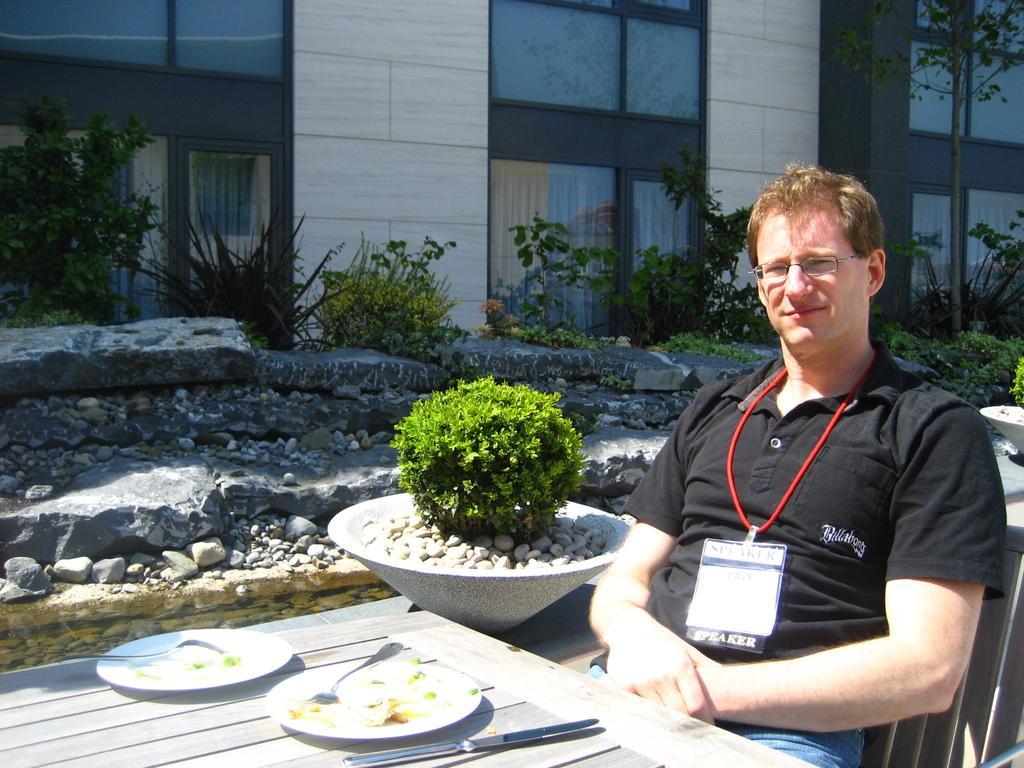Please provide a concise description of this image. In this picture we can see a man, he is seated on the chair, in front of him we can find plates and spoons on the table, beside to him we can find few plants and buildings. 